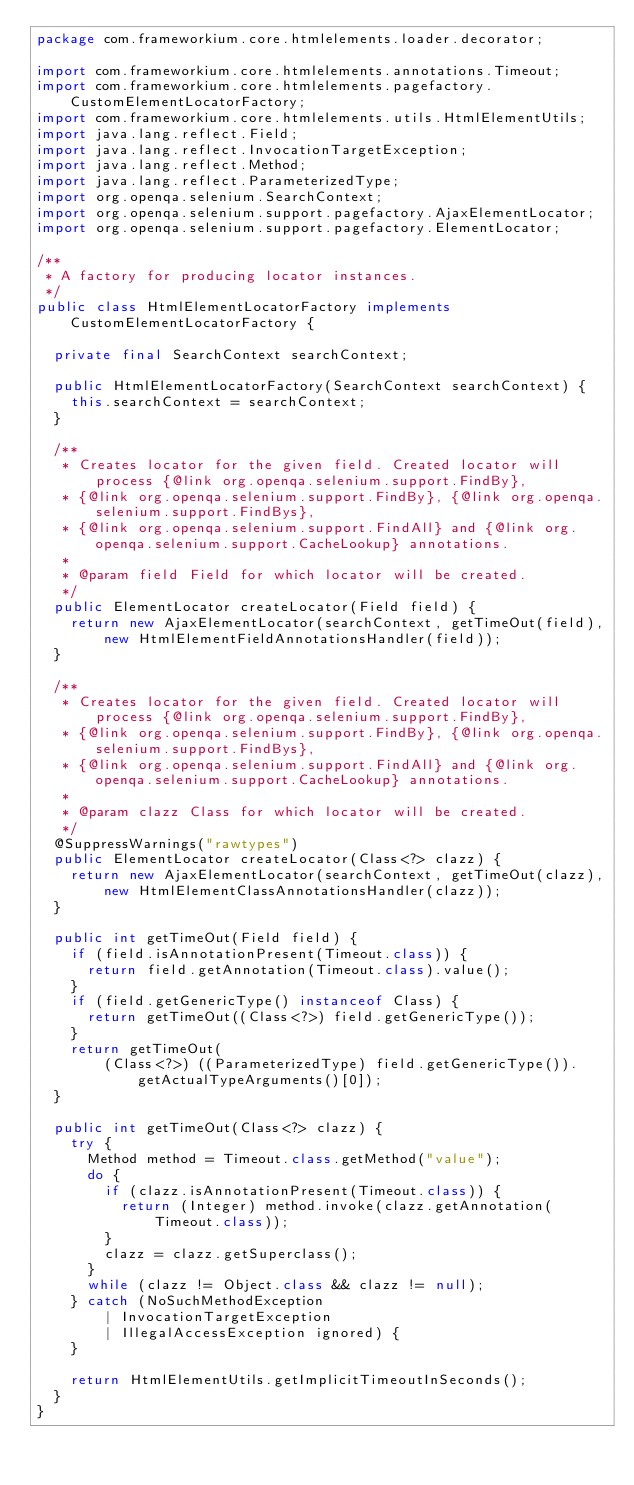<code> <loc_0><loc_0><loc_500><loc_500><_Java_>package com.frameworkium.core.htmlelements.loader.decorator;

import com.frameworkium.core.htmlelements.annotations.Timeout;
import com.frameworkium.core.htmlelements.pagefactory.CustomElementLocatorFactory;
import com.frameworkium.core.htmlelements.utils.HtmlElementUtils;
import java.lang.reflect.Field;
import java.lang.reflect.InvocationTargetException;
import java.lang.reflect.Method;
import java.lang.reflect.ParameterizedType;
import org.openqa.selenium.SearchContext;
import org.openqa.selenium.support.pagefactory.AjaxElementLocator;
import org.openqa.selenium.support.pagefactory.ElementLocator;

/**
 * A factory for producing locator instances.
 */
public class HtmlElementLocatorFactory implements CustomElementLocatorFactory {

  private final SearchContext searchContext;

  public HtmlElementLocatorFactory(SearchContext searchContext) {
    this.searchContext = searchContext;
  }

  /**
   * Creates locator for the given field. Created locator will process {@link org.openqa.selenium.support.FindBy},
   * {@link org.openqa.selenium.support.FindBy}, {@link org.openqa.selenium.support.FindBys},
   * {@link org.openqa.selenium.support.FindAll} and {@link org.openqa.selenium.support.CacheLookup} annotations.
   *
   * @param field Field for which locator will be created.
   */
  public ElementLocator createLocator(Field field) {
    return new AjaxElementLocator(searchContext, getTimeOut(field),
        new HtmlElementFieldAnnotationsHandler(field));
  }

  /**
   * Creates locator for the given field. Created locator will process {@link org.openqa.selenium.support.FindBy},
   * {@link org.openqa.selenium.support.FindBy}, {@link org.openqa.selenium.support.FindBys},
   * {@link org.openqa.selenium.support.FindAll} and {@link org.openqa.selenium.support.CacheLookup} annotations.
   *
   * @param clazz Class for which locator will be created.
   */
  @SuppressWarnings("rawtypes")
  public ElementLocator createLocator(Class<?> clazz) {
    return new AjaxElementLocator(searchContext, getTimeOut(clazz),
        new HtmlElementClassAnnotationsHandler(clazz));
  }

  public int getTimeOut(Field field) {
    if (field.isAnnotationPresent(Timeout.class)) {
      return field.getAnnotation(Timeout.class).value();
    }
    if (field.getGenericType() instanceof Class) {
      return getTimeOut((Class<?>) field.getGenericType());
    }
    return getTimeOut(
        (Class<?>) ((ParameterizedType) field.getGenericType()).getActualTypeArguments()[0]);
  }

  public int getTimeOut(Class<?> clazz) {
    try {
      Method method = Timeout.class.getMethod("value");
      do {
        if (clazz.isAnnotationPresent(Timeout.class)) {
          return (Integer) method.invoke(clazz.getAnnotation(Timeout.class));
        }
        clazz = clazz.getSuperclass();
      }
      while (clazz != Object.class && clazz != null);
    } catch (NoSuchMethodException
        | InvocationTargetException
        | IllegalAccessException ignored) {
    }

    return HtmlElementUtils.getImplicitTimeoutInSeconds();
  }
}
</code> 